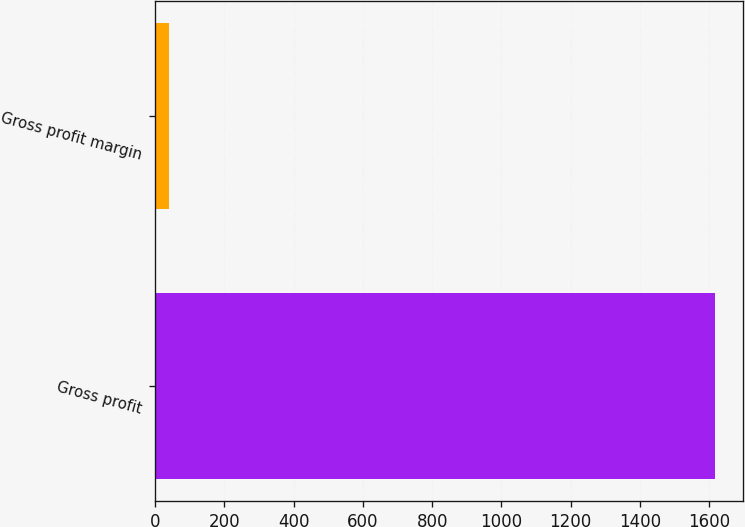Convert chart to OTSL. <chart><loc_0><loc_0><loc_500><loc_500><bar_chart><fcel>Gross profit<fcel>Gross profit margin<nl><fcel>1617.8<fcel>40.3<nl></chart> 